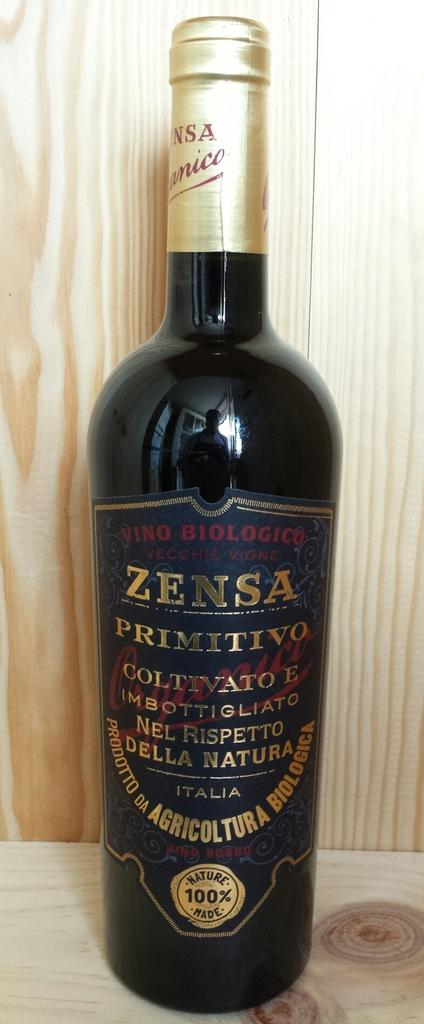<image>
Render a clear and concise summary of the photo. a bottle of Zensa Primitivo displayed on a wooden table 